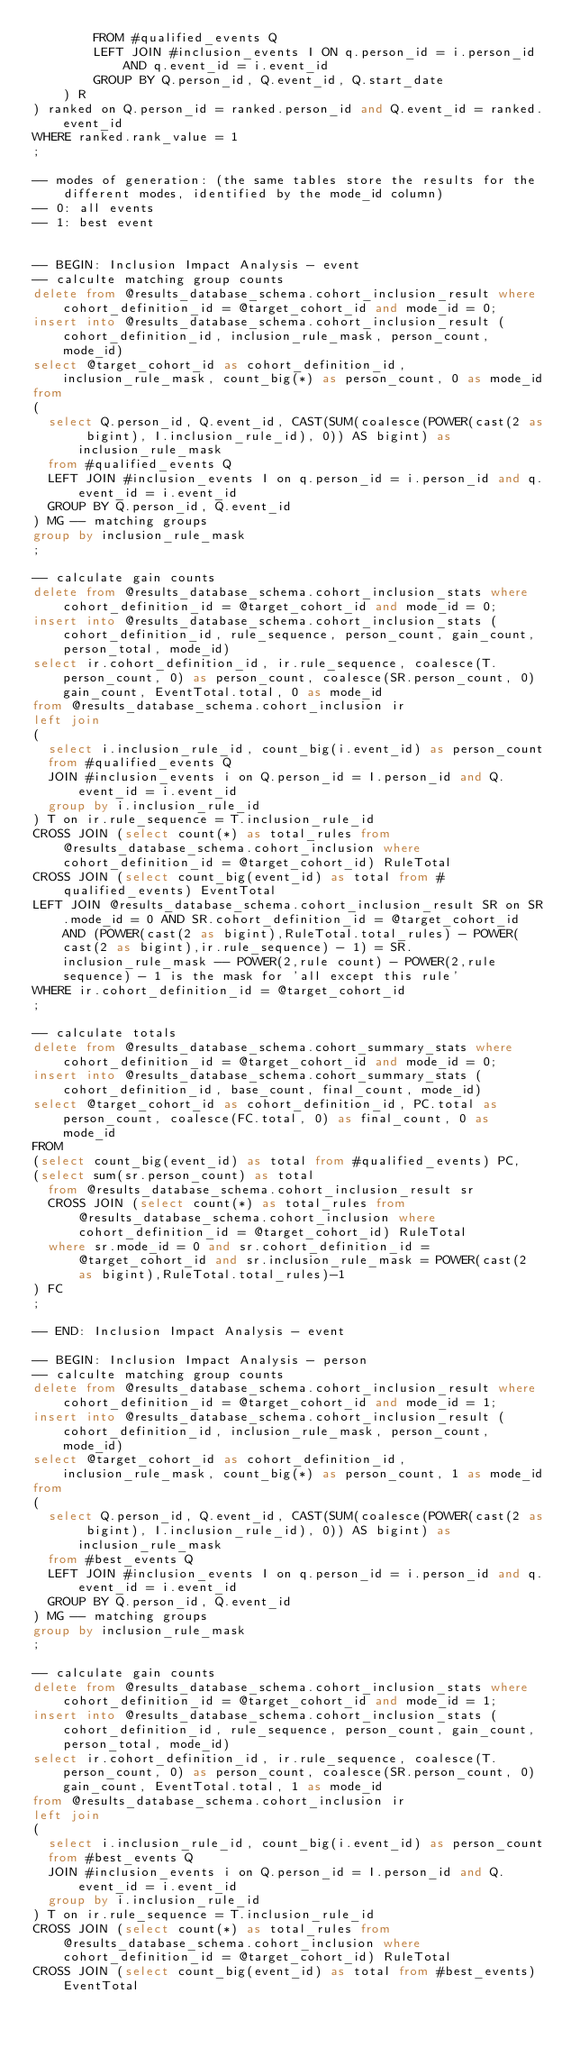Convert code to text. <code><loc_0><loc_0><loc_500><loc_500><_SQL_>		FROM #qualified_events Q
		LEFT JOIN #inclusion_events I ON q.person_id = i.person_id AND q.event_id = i.event_id
		GROUP BY Q.person_id, Q.event_id, Q.start_date
	) R
) ranked on Q.person_id = ranked.person_id and Q.event_id = ranked.event_id
WHERE ranked.rank_value = 1
;

-- modes of generation: (the same tables store the results for the different modes, identified by the mode_id column)
-- 0: all events
-- 1: best event


-- BEGIN: Inclusion Impact Analysis - event
-- calculte matching group counts
delete from @results_database_schema.cohort_inclusion_result where cohort_definition_id = @target_cohort_id and mode_id = 0;
insert into @results_database_schema.cohort_inclusion_result (cohort_definition_id, inclusion_rule_mask, person_count, mode_id)
select @target_cohort_id as cohort_definition_id, inclusion_rule_mask, count_big(*) as person_count, 0 as mode_id
from
(
  select Q.person_id, Q.event_id, CAST(SUM(coalesce(POWER(cast(2 as bigint), I.inclusion_rule_id), 0)) AS bigint) as inclusion_rule_mask
  from #qualified_events Q
  LEFT JOIN #inclusion_events I on q.person_id = i.person_id and q.event_id = i.event_id
  GROUP BY Q.person_id, Q.event_id
) MG -- matching groups
group by inclusion_rule_mask
;

-- calculate gain counts 
delete from @results_database_schema.cohort_inclusion_stats where cohort_definition_id = @target_cohort_id and mode_id = 0;
insert into @results_database_schema.cohort_inclusion_stats (cohort_definition_id, rule_sequence, person_count, gain_count, person_total, mode_id)
select ir.cohort_definition_id, ir.rule_sequence, coalesce(T.person_count, 0) as person_count, coalesce(SR.person_count, 0) gain_count, EventTotal.total, 0 as mode_id
from @results_database_schema.cohort_inclusion ir
left join
(
  select i.inclusion_rule_id, count_big(i.event_id) as person_count
  from #qualified_events Q
  JOIN #inclusion_events i on Q.person_id = I.person_id and Q.event_id = i.event_id
  group by i.inclusion_rule_id
) T on ir.rule_sequence = T.inclusion_rule_id
CROSS JOIN (select count(*) as total_rules from @results_database_schema.cohort_inclusion where cohort_definition_id = @target_cohort_id) RuleTotal
CROSS JOIN (select count_big(event_id) as total from #qualified_events) EventTotal
LEFT JOIN @results_database_schema.cohort_inclusion_result SR on SR.mode_id = 0 AND SR.cohort_definition_id = @target_cohort_id AND (POWER(cast(2 as bigint),RuleTotal.total_rules) - POWER(cast(2 as bigint),ir.rule_sequence) - 1) = SR.inclusion_rule_mask -- POWER(2,rule count) - POWER(2,rule sequence) - 1 is the mask for 'all except this rule'
WHERE ir.cohort_definition_id = @target_cohort_id
;

-- calculate totals
delete from @results_database_schema.cohort_summary_stats where cohort_definition_id = @target_cohort_id and mode_id = 0;
insert into @results_database_schema.cohort_summary_stats (cohort_definition_id, base_count, final_count, mode_id)
select @target_cohort_id as cohort_definition_id, PC.total as person_count, coalesce(FC.total, 0) as final_count, 0 as mode_id
FROM
(select count_big(event_id) as total from #qualified_events) PC,
(select sum(sr.person_count) as total
  from @results_database_schema.cohort_inclusion_result sr
  CROSS JOIN (select count(*) as total_rules from @results_database_schema.cohort_inclusion where cohort_definition_id = @target_cohort_id) RuleTotal
  where sr.mode_id = 0 and sr.cohort_definition_id = @target_cohort_id and sr.inclusion_rule_mask = POWER(cast(2 as bigint),RuleTotal.total_rules)-1
) FC
;

-- END: Inclusion Impact Analysis - event

-- BEGIN: Inclusion Impact Analysis - person
-- calculte matching group counts
delete from @results_database_schema.cohort_inclusion_result where cohort_definition_id = @target_cohort_id and mode_id = 1;
insert into @results_database_schema.cohort_inclusion_result (cohort_definition_id, inclusion_rule_mask, person_count, mode_id)
select @target_cohort_id as cohort_definition_id, inclusion_rule_mask, count_big(*) as person_count, 1 as mode_id
from
(
  select Q.person_id, Q.event_id, CAST(SUM(coalesce(POWER(cast(2 as bigint), I.inclusion_rule_id), 0)) AS bigint) as inclusion_rule_mask
  from #best_events Q
  LEFT JOIN #inclusion_events I on q.person_id = i.person_id and q.event_id = i.event_id
  GROUP BY Q.person_id, Q.event_id
) MG -- matching groups
group by inclusion_rule_mask
;

-- calculate gain counts 
delete from @results_database_schema.cohort_inclusion_stats where cohort_definition_id = @target_cohort_id and mode_id = 1;
insert into @results_database_schema.cohort_inclusion_stats (cohort_definition_id, rule_sequence, person_count, gain_count, person_total, mode_id)
select ir.cohort_definition_id, ir.rule_sequence, coalesce(T.person_count, 0) as person_count, coalesce(SR.person_count, 0) gain_count, EventTotal.total, 1 as mode_id
from @results_database_schema.cohort_inclusion ir
left join
(
  select i.inclusion_rule_id, count_big(i.event_id) as person_count
  from #best_events Q
  JOIN #inclusion_events i on Q.person_id = I.person_id and Q.event_id = i.event_id
  group by i.inclusion_rule_id
) T on ir.rule_sequence = T.inclusion_rule_id
CROSS JOIN (select count(*) as total_rules from @results_database_schema.cohort_inclusion where cohort_definition_id = @target_cohort_id) RuleTotal
CROSS JOIN (select count_big(event_id) as total from #best_events) EventTotal</code> 